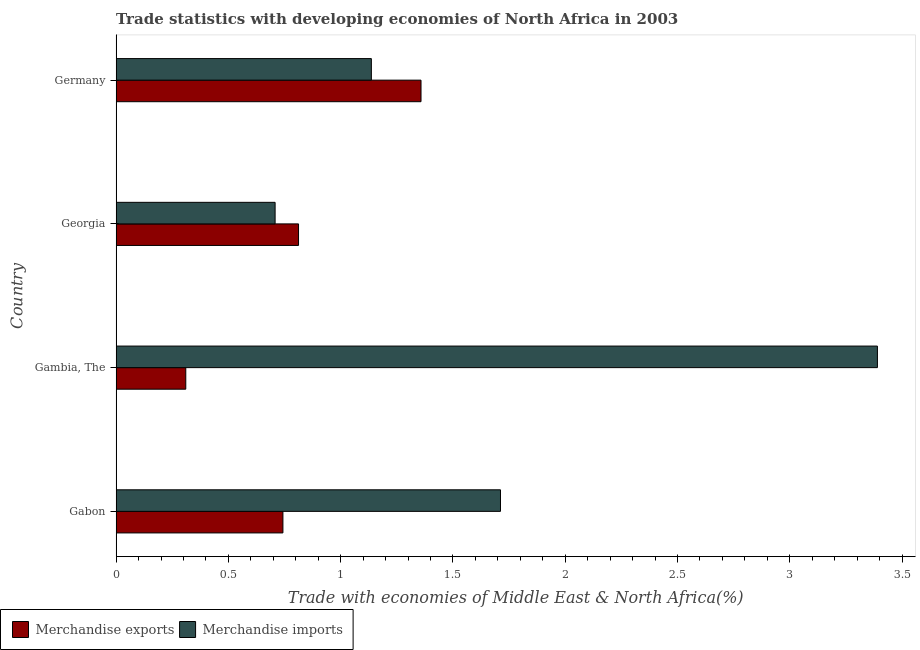Are the number of bars on each tick of the Y-axis equal?
Your answer should be very brief. Yes. How many bars are there on the 2nd tick from the bottom?
Give a very brief answer. 2. What is the label of the 4th group of bars from the top?
Provide a short and direct response. Gabon. In how many cases, is the number of bars for a given country not equal to the number of legend labels?
Offer a very short reply. 0. What is the merchandise imports in Georgia?
Offer a very short reply. 0.71. Across all countries, what is the maximum merchandise exports?
Ensure brevity in your answer.  1.36. Across all countries, what is the minimum merchandise imports?
Offer a very short reply. 0.71. In which country was the merchandise imports maximum?
Keep it short and to the point. Gambia, The. In which country was the merchandise exports minimum?
Provide a short and direct response. Gambia, The. What is the total merchandise imports in the graph?
Ensure brevity in your answer.  6.95. What is the difference between the merchandise imports in Gambia, The and that in Georgia?
Give a very brief answer. 2.68. What is the difference between the merchandise imports in Gambia, The and the merchandise exports in Gabon?
Provide a short and direct response. 2.65. What is the average merchandise imports per country?
Keep it short and to the point. 1.74. What is the difference between the merchandise exports and merchandise imports in Georgia?
Give a very brief answer. 0.1. What is the ratio of the merchandise exports in Gabon to that in Gambia, The?
Provide a short and direct response. 2.4. What is the difference between the highest and the second highest merchandise exports?
Offer a very short reply. 0.55. What is the difference between the highest and the lowest merchandise imports?
Provide a succinct answer. 2.68. Is the sum of the merchandise exports in Gabon and Georgia greater than the maximum merchandise imports across all countries?
Your answer should be compact. No. How many bars are there?
Provide a short and direct response. 8. How many countries are there in the graph?
Offer a very short reply. 4. Are the values on the major ticks of X-axis written in scientific E-notation?
Your answer should be very brief. No. What is the title of the graph?
Offer a terse response. Trade statistics with developing economies of North Africa in 2003. What is the label or title of the X-axis?
Keep it short and to the point. Trade with economies of Middle East & North Africa(%). What is the Trade with economies of Middle East & North Africa(%) of Merchandise exports in Gabon?
Your answer should be compact. 0.74. What is the Trade with economies of Middle East & North Africa(%) in Merchandise imports in Gabon?
Your answer should be compact. 1.71. What is the Trade with economies of Middle East & North Africa(%) of Merchandise exports in Gambia, The?
Make the answer very short. 0.31. What is the Trade with economies of Middle East & North Africa(%) of Merchandise imports in Gambia, The?
Provide a succinct answer. 3.39. What is the Trade with economies of Middle East & North Africa(%) in Merchandise exports in Georgia?
Give a very brief answer. 0.81. What is the Trade with economies of Middle East & North Africa(%) in Merchandise imports in Georgia?
Provide a succinct answer. 0.71. What is the Trade with economies of Middle East & North Africa(%) in Merchandise exports in Germany?
Provide a succinct answer. 1.36. What is the Trade with economies of Middle East & North Africa(%) of Merchandise imports in Germany?
Ensure brevity in your answer.  1.14. Across all countries, what is the maximum Trade with economies of Middle East & North Africa(%) of Merchandise exports?
Make the answer very short. 1.36. Across all countries, what is the maximum Trade with economies of Middle East & North Africa(%) of Merchandise imports?
Offer a terse response. 3.39. Across all countries, what is the minimum Trade with economies of Middle East & North Africa(%) of Merchandise exports?
Your response must be concise. 0.31. Across all countries, what is the minimum Trade with economies of Middle East & North Africa(%) in Merchandise imports?
Keep it short and to the point. 0.71. What is the total Trade with economies of Middle East & North Africa(%) in Merchandise exports in the graph?
Provide a short and direct response. 3.22. What is the total Trade with economies of Middle East & North Africa(%) of Merchandise imports in the graph?
Give a very brief answer. 6.95. What is the difference between the Trade with economies of Middle East & North Africa(%) in Merchandise exports in Gabon and that in Gambia, The?
Offer a very short reply. 0.43. What is the difference between the Trade with economies of Middle East & North Africa(%) of Merchandise imports in Gabon and that in Gambia, The?
Your response must be concise. -1.68. What is the difference between the Trade with economies of Middle East & North Africa(%) of Merchandise exports in Gabon and that in Georgia?
Your answer should be very brief. -0.07. What is the difference between the Trade with economies of Middle East & North Africa(%) in Merchandise imports in Gabon and that in Georgia?
Your response must be concise. 1. What is the difference between the Trade with economies of Middle East & North Africa(%) in Merchandise exports in Gabon and that in Germany?
Offer a terse response. -0.61. What is the difference between the Trade with economies of Middle East & North Africa(%) in Merchandise imports in Gabon and that in Germany?
Make the answer very short. 0.57. What is the difference between the Trade with economies of Middle East & North Africa(%) in Merchandise exports in Gambia, The and that in Georgia?
Provide a short and direct response. -0.5. What is the difference between the Trade with economies of Middle East & North Africa(%) of Merchandise imports in Gambia, The and that in Georgia?
Provide a short and direct response. 2.68. What is the difference between the Trade with economies of Middle East & North Africa(%) of Merchandise exports in Gambia, The and that in Germany?
Your response must be concise. -1.05. What is the difference between the Trade with economies of Middle East & North Africa(%) of Merchandise imports in Gambia, The and that in Germany?
Your response must be concise. 2.25. What is the difference between the Trade with economies of Middle East & North Africa(%) of Merchandise exports in Georgia and that in Germany?
Provide a succinct answer. -0.55. What is the difference between the Trade with economies of Middle East & North Africa(%) of Merchandise imports in Georgia and that in Germany?
Your answer should be compact. -0.43. What is the difference between the Trade with economies of Middle East & North Africa(%) in Merchandise exports in Gabon and the Trade with economies of Middle East & North Africa(%) in Merchandise imports in Gambia, The?
Keep it short and to the point. -2.65. What is the difference between the Trade with economies of Middle East & North Africa(%) of Merchandise exports in Gabon and the Trade with economies of Middle East & North Africa(%) of Merchandise imports in Georgia?
Provide a succinct answer. 0.03. What is the difference between the Trade with economies of Middle East & North Africa(%) of Merchandise exports in Gabon and the Trade with economies of Middle East & North Africa(%) of Merchandise imports in Germany?
Keep it short and to the point. -0.39. What is the difference between the Trade with economies of Middle East & North Africa(%) in Merchandise exports in Gambia, The and the Trade with economies of Middle East & North Africa(%) in Merchandise imports in Georgia?
Your answer should be very brief. -0.4. What is the difference between the Trade with economies of Middle East & North Africa(%) of Merchandise exports in Gambia, The and the Trade with economies of Middle East & North Africa(%) of Merchandise imports in Germany?
Give a very brief answer. -0.83. What is the difference between the Trade with economies of Middle East & North Africa(%) in Merchandise exports in Georgia and the Trade with economies of Middle East & North Africa(%) in Merchandise imports in Germany?
Give a very brief answer. -0.32. What is the average Trade with economies of Middle East & North Africa(%) of Merchandise exports per country?
Ensure brevity in your answer.  0.81. What is the average Trade with economies of Middle East & North Africa(%) of Merchandise imports per country?
Offer a very short reply. 1.74. What is the difference between the Trade with economies of Middle East & North Africa(%) of Merchandise exports and Trade with economies of Middle East & North Africa(%) of Merchandise imports in Gabon?
Your response must be concise. -0.97. What is the difference between the Trade with economies of Middle East & North Africa(%) of Merchandise exports and Trade with economies of Middle East & North Africa(%) of Merchandise imports in Gambia, The?
Provide a short and direct response. -3.08. What is the difference between the Trade with economies of Middle East & North Africa(%) of Merchandise exports and Trade with economies of Middle East & North Africa(%) of Merchandise imports in Georgia?
Offer a very short reply. 0.1. What is the difference between the Trade with economies of Middle East & North Africa(%) in Merchandise exports and Trade with economies of Middle East & North Africa(%) in Merchandise imports in Germany?
Make the answer very short. 0.22. What is the ratio of the Trade with economies of Middle East & North Africa(%) in Merchandise exports in Gabon to that in Gambia, The?
Your response must be concise. 2.39. What is the ratio of the Trade with economies of Middle East & North Africa(%) of Merchandise imports in Gabon to that in Gambia, The?
Your response must be concise. 0.5. What is the ratio of the Trade with economies of Middle East & North Africa(%) of Merchandise exports in Gabon to that in Georgia?
Keep it short and to the point. 0.91. What is the ratio of the Trade with economies of Middle East & North Africa(%) of Merchandise imports in Gabon to that in Georgia?
Provide a short and direct response. 2.42. What is the ratio of the Trade with economies of Middle East & North Africa(%) of Merchandise exports in Gabon to that in Germany?
Give a very brief answer. 0.55. What is the ratio of the Trade with economies of Middle East & North Africa(%) in Merchandise imports in Gabon to that in Germany?
Your response must be concise. 1.51. What is the ratio of the Trade with economies of Middle East & North Africa(%) in Merchandise exports in Gambia, The to that in Georgia?
Your answer should be compact. 0.38. What is the ratio of the Trade with economies of Middle East & North Africa(%) in Merchandise imports in Gambia, The to that in Georgia?
Your answer should be compact. 4.79. What is the ratio of the Trade with economies of Middle East & North Africa(%) in Merchandise exports in Gambia, The to that in Germany?
Your response must be concise. 0.23. What is the ratio of the Trade with economies of Middle East & North Africa(%) of Merchandise imports in Gambia, The to that in Germany?
Make the answer very short. 2.98. What is the ratio of the Trade with economies of Middle East & North Africa(%) in Merchandise exports in Georgia to that in Germany?
Your answer should be very brief. 0.6. What is the ratio of the Trade with economies of Middle East & North Africa(%) in Merchandise imports in Georgia to that in Germany?
Give a very brief answer. 0.62. What is the difference between the highest and the second highest Trade with economies of Middle East & North Africa(%) in Merchandise exports?
Your answer should be compact. 0.55. What is the difference between the highest and the second highest Trade with economies of Middle East & North Africa(%) in Merchandise imports?
Your answer should be compact. 1.68. What is the difference between the highest and the lowest Trade with economies of Middle East & North Africa(%) in Merchandise exports?
Make the answer very short. 1.05. What is the difference between the highest and the lowest Trade with economies of Middle East & North Africa(%) of Merchandise imports?
Provide a succinct answer. 2.68. 